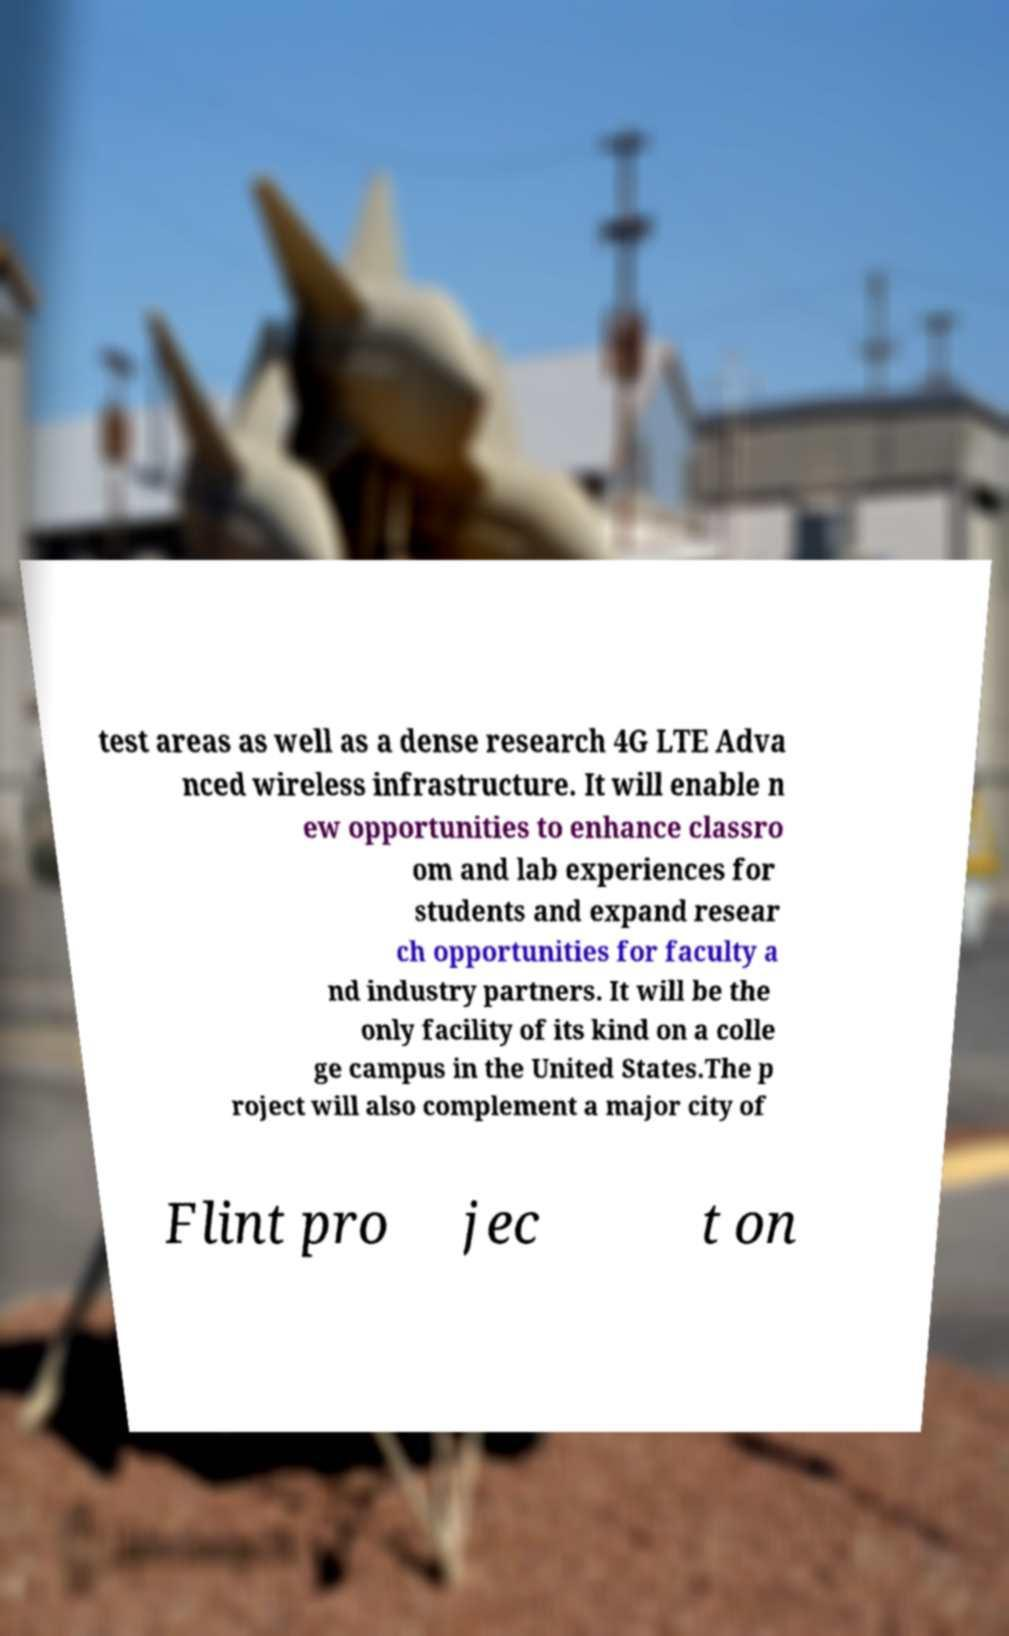What messages or text are displayed in this image? I need them in a readable, typed format. test areas as well as a dense research 4G LTE Adva nced wireless infrastructure. It will enable n ew opportunities to enhance classro om and lab experiences for students and expand resear ch opportunities for faculty a nd industry partners. It will be the only facility of its kind on a colle ge campus in the United States.The p roject will also complement a major city of Flint pro jec t on 